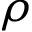Convert formula to latex. <formula><loc_0><loc_0><loc_500><loc_500>\rho</formula> 